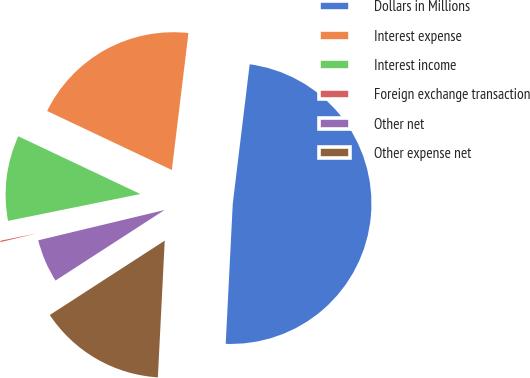<chart> <loc_0><loc_0><loc_500><loc_500><pie_chart><fcel>Dollars in Millions<fcel>Interest expense<fcel>Interest income<fcel>Foreign exchange transaction<fcel>Other net<fcel>Other expense net<nl><fcel>48.88%<fcel>19.89%<fcel>10.22%<fcel>0.56%<fcel>5.39%<fcel>15.06%<nl></chart> 